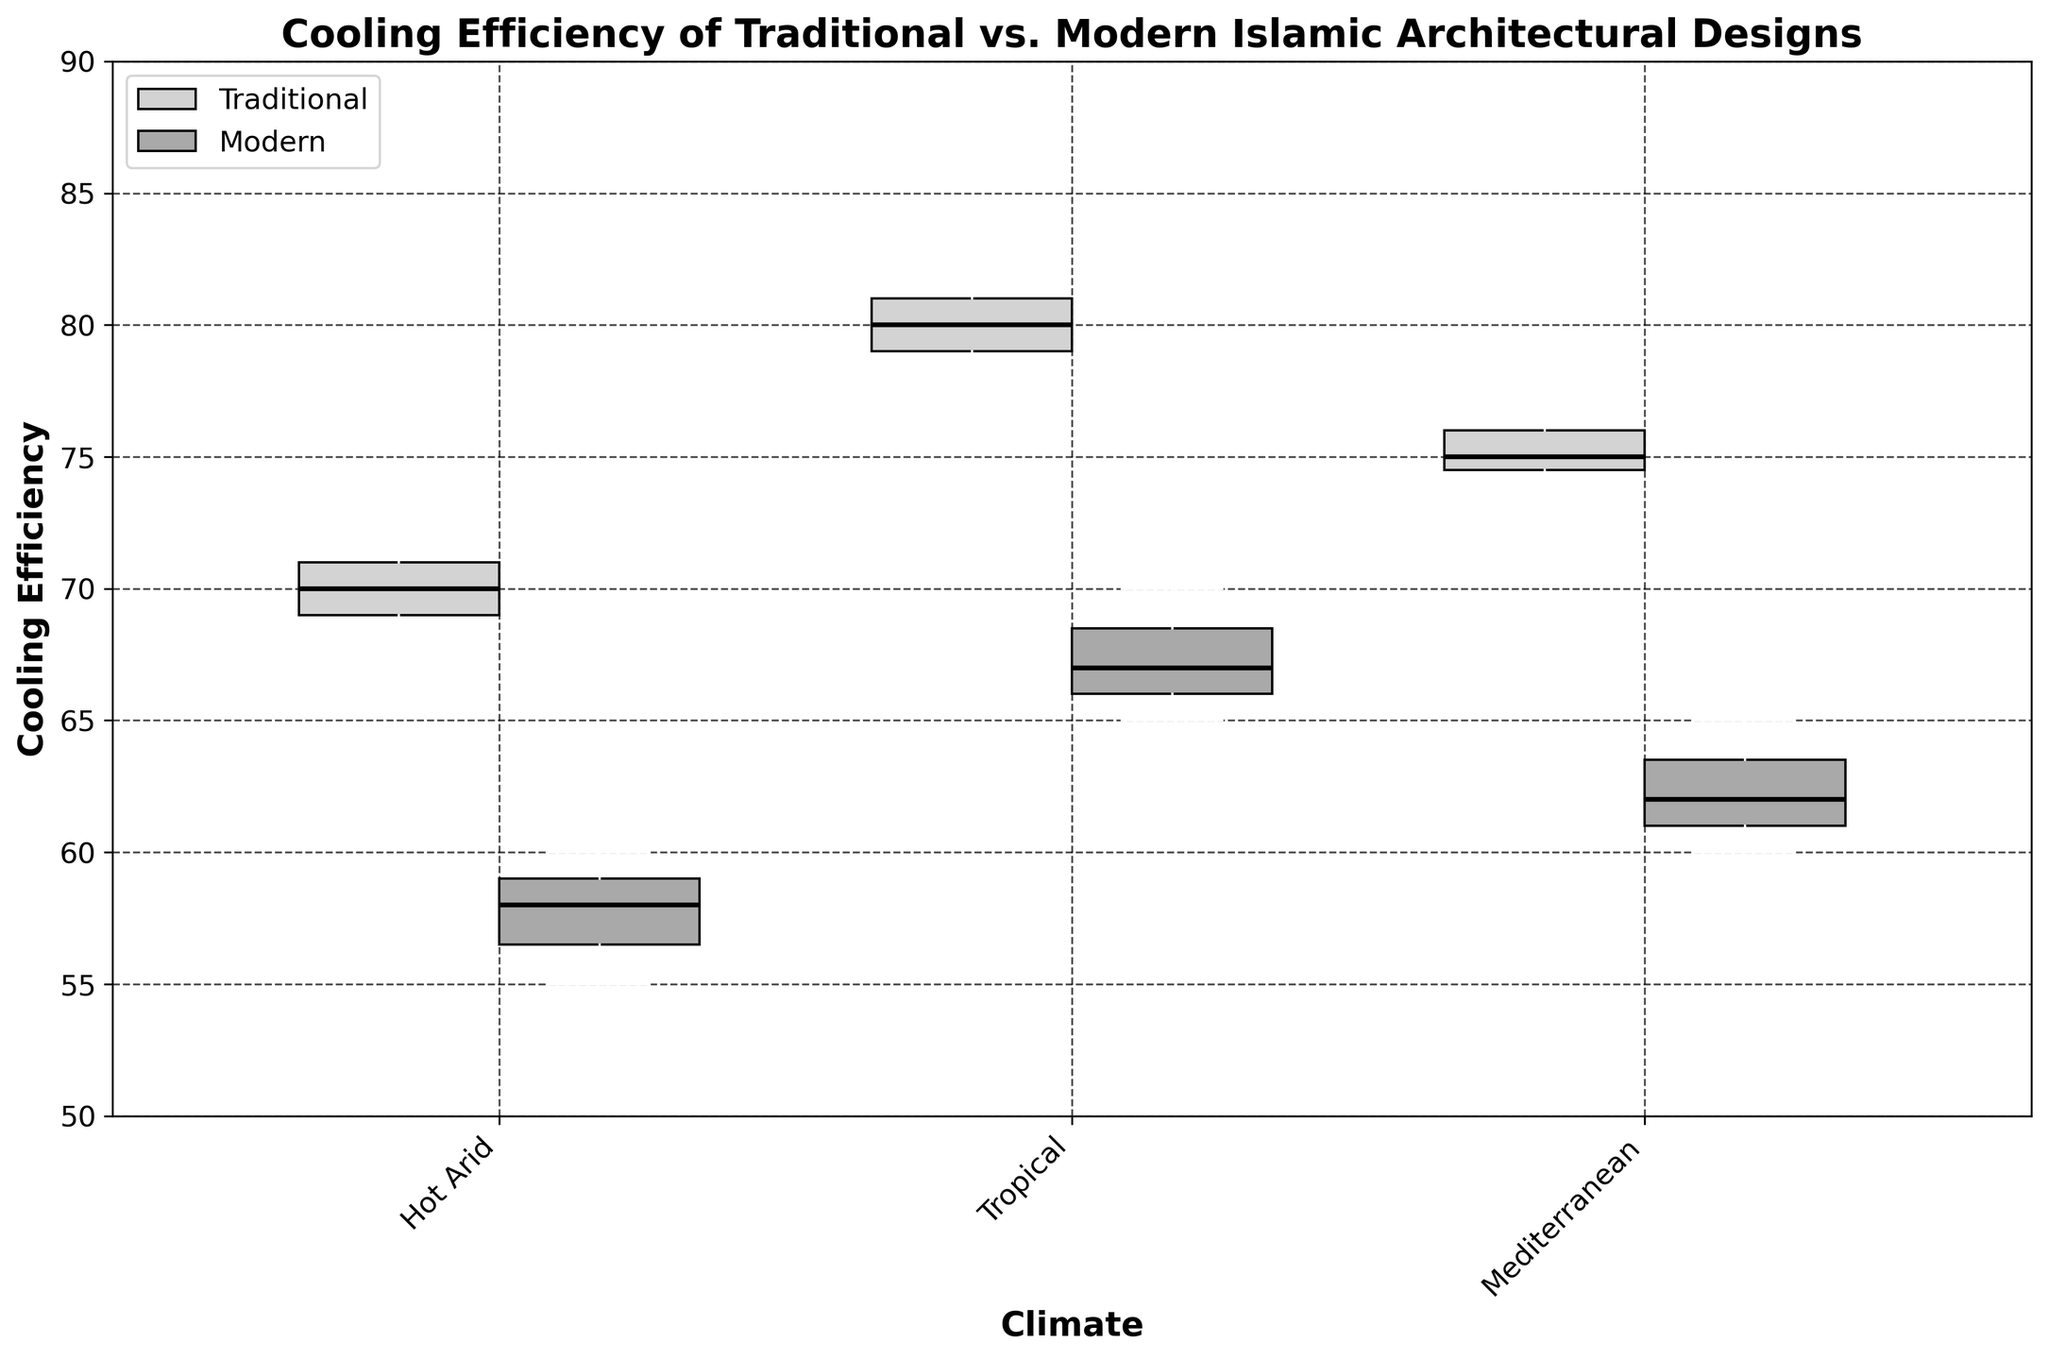What's the title of the figure? The title is typically located at the top of the figure and provides a concise description of what the figure is demonstrating.
Answer: Cooling Efficiency of Traditional vs. Modern Islamic Architectural Designs What are the labels for the x and y axes? The labels for the axes are usually found along the horizontal and vertical lines of the plot. The x-axis label describes what the horizontal axis represents, and the y-axis label describes what the vertical axis represents.
Answer: The x-axis label is 'Climate', and the y-axis label is 'Cooling Efficiency' What is the range of cooling efficiency values shown on the y-axis? The y-axis typically has tick marks and numerical labels that indicate the range of values being represented.
Answer: 50 to 90 What climates are represented in the figure? The x-axis typically has tick marks with labels that indicate the groups or categories being represented.
Answer: Hot Arid, Tropical, Mediterranean In which climate do Traditional designs have the highest median cooling efficiency? To find this, look at the box plots for Traditional designs across all climates and identify which has the highest median line.
Answer: Tropical Compare the median cooling efficiency of Traditional and Modern designs in the Hot Arid climate. Which is higher? Find the median (usually the line inside the box) for both Traditional and Modern design box plots in the Hot Arid climate and compare their heights.
Answer: Traditional Which design shows the greatest spread (IQR) in cooling efficiency values in the Mediterranean climate? The spread or Interquartile Range (IQR) is the width of the box in the box plot. Compare the widths of the boxes for Traditional and Modern designs in the Mediterranean climate.
Answer: Modern Are there any outliers in the Tropical climate for Modern designs? Outliers in a box plot are usually represented by individual points outside the whiskers. Check the Modern design box plot in the Tropical climate for such points.
Answer: No By how much does the median cooling efficiency of Traditional designs in the Tropical climate exceed that of Modern designs in the same climate? Identify the median value for Traditional and Modern designs in the Tropical climate, then calculate the difference between them.
Answer: 13 In which climate is the difference between Traditional and Modern designs' median cooling efficiency the smallest? Calculate the difference between the medians of Traditional and Modern designs across all climates and identify the smallest difference.
Answer: Hot Arid 